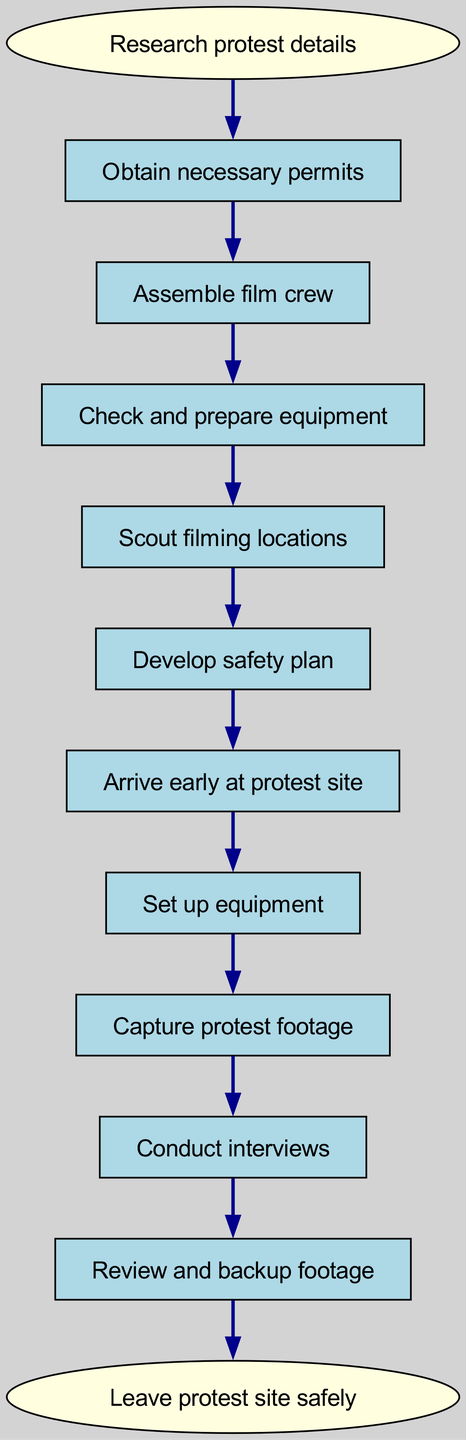What is the first step in the process? The diagram indicates that the first step in the flow chart is "Research protest details," which is located at the top of the flow.
Answer: Research protest details How many nodes are in the diagram? By counting all the distinct elements listed in the diagram, there are 11 nodes total, including the start and end points.
Answer: 11 What action follows after assembling the film crew? Based on the connections in the diagram, the next action after "Assemble film crew" is "Check and prepare equipment."
Answer: Check and prepare equipment Which step comes before reviewing and backing up footage? The diagram shows that "Conduct interviews" is the step that occurs immediately prior to "Review and backup footage."
Answer: Conduct interviews Is "Leave protest site safely" a starting or ending step? The "Leave protest site safely" node appears at the bottom of the flow chart and is indicated as the end step.
Answer: Ending step What action can be performed after capturing protest footage? According to the flow, "Conduct interviews" is the action that comes directly after capturing protest footage.
Answer: Conduct interviews Which step requires ensuring safety before arriving at the protest site? The diagram depicts that "Develop safety plan" is the action following "Scout filming locations" and before "Arrive early at protest site."
Answer: Develop safety plan How many connections are there between nodes? By reviewing the connections listed, there are 10 connections that link the various steps from the start to the end.
Answer: 10 What is the second step in planning the filming? The second step identified in the flow chart is "Obtain necessary permits," following the first step of researching protest details.
Answer: Obtain necessary permits 